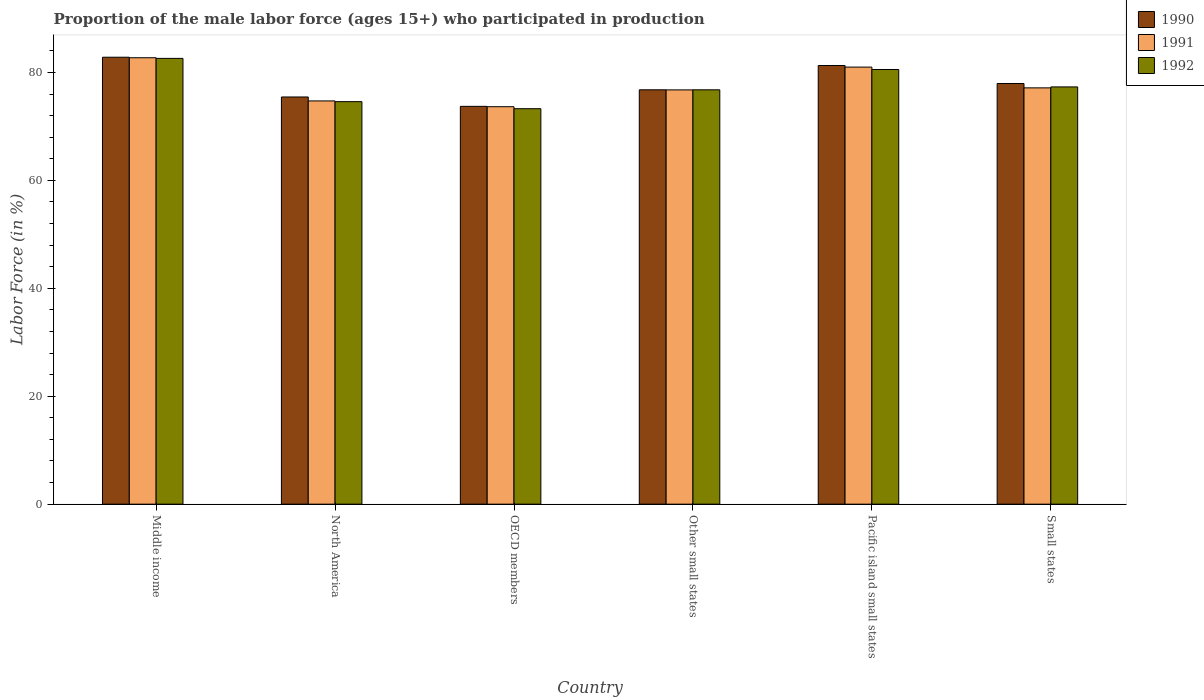How many different coloured bars are there?
Provide a succinct answer. 3. Are the number of bars per tick equal to the number of legend labels?
Your answer should be compact. Yes. Are the number of bars on each tick of the X-axis equal?
Your answer should be compact. Yes. What is the label of the 6th group of bars from the left?
Your answer should be very brief. Small states. What is the proportion of the male labor force who participated in production in 1992 in North America?
Make the answer very short. 74.6. Across all countries, what is the maximum proportion of the male labor force who participated in production in 1992?
Your answer should be very brief. 82.61. Across all countries, what is the minimum proportion of the male labor force who participated in production in 1990?
Make the answer very short. 73.73. What is the total proportion of the male labor force who participated in production in 1991 in the graph?
Keep it short and to the point. 466.05. What is the difference between the proportion of the male labor force who participated in production in 1990 in North America and that in Small states?
Keep it short and to the point. -2.5. What is the difference between the proportion of the male labor force who participated in production in 1991 in Middle income and the proportion of the male labor force who participated in production in 1992 in Pacific island small states?
Keep it short and to the point. 2.18. What is the average proportion of the male labor force who participated in production in 1991 per country?
Provide a succinct answer. 77.67. What is the difference between the proportion of the male labor force who participated in production of/in 1991 and proportion of the male labor force who participated in production of/in 1992 in Middle income?
Give a very brief answer. 0.12. What is the ratio of the proportion of the male labor force who participated in production in 1990 in Middle income to that in Pacific island small states?
Your answer should be compact. 1.02. What is the difference between the highest and the second highest proportion of the male labor force who participated in production in 1992?
Offer a very short reply. -2.06. What is the difference between the highest and the lowest proportion of the male labor force who participated in production in 1992?
Make the answer very short. 9.32. How many bars are there?
Your answer should be very brief. 18. Are all the bars in the graph horizontal?
Give a very brief answer. No. Does the graph contain any zero values?
Provide a short and direct response. No. What is the title of the graph?
Ensure brevity in your answer.  Proportion of the male labor force (ages 15+) who participated in production. Does "1964" appear as one of the legend labels in the graph?
Make the answer very short. No. What is the label or title of the Y-axis?
Provide a short and direct response. Labor Force (in %). What is the Labor Force (in %) of 1990 in Middle income?
Your response must be concise. 82.83. What is the Labor Force (in %) of 1991 in Middle income?
Offer a terse response. 82.73. What is the Labor Force (in %) in 1992 in Middle income?
Make the answer very short. 82.61. What is the Labor Force (in %) in 1990 in North America?
Offer a terse response. 75.46. What is the Labor Force (in %) in 1991 in North America?
Ensure brevity in your answer.  74.73. What is the Labor Force (in %) in 1992 in North America?
Offer a very short reply. 74.6. What is the Labor Force (in %) in 1990 in OECD members?
Your answer should be compact. 73.73. What is the Labor Force (in %) in 1991 in OECD members?
Keep it short and to the point. 73.66. What is the Labor Force (in %) in 1992 in OECD members?
Make the answer very short. 73.29. What is the Labor Force (in %) of 1990 in Other small states?
Your response must be concise. 76.79. What is the Labor Force (in %) of 1991 in Other small states?
Your response must be concise. 76.78. What is the Labor Force (in %) in 1992 in Other small states?
Provide a short and direct response. 76.79. What is the Labor Force (in %) of 1990 in Pacific island small states?
Provide a succinct answer. 81.29. What is the Labor Force (in %) of 1991 in Pacific island small states?
Provide a short and direct response. 81. What is the Labor Force (in %) of 1992 in Pacific island small states?
Make the answer very short. 80.56. What is the Labor Force (in %) of 1990 in Small states?
Offer a very short reply. 77.96. What is the Labor Force (in %) in 1991 in Small states?
Your response must be concise. 77.15. What is the Labor Force (in %) of 1992 in Small states?
Keep it short and to the point. 77.33. Across all countries, what is the maximum Labor Force (in %) in 1990?
Ensure brevity in your answer.  82.83. Across all countries, what is the maximum Labor Force (in %) of 1991?
Offer a very short reply. 82.73. Across all countries, what is the maximum Labor Force (in %) in 1992?
Keep it short and to the point. 82.61. Across all countries, what is the minimum Labor Force (in %) of 1990?
Ensure brevity in your answer.  73.73. Across all countries, what is the minimum Labor Force (in %) in 1991?
Provide a succinct answer. 73.66. Across all countries, what is the minimum Labor Force (in %) of 1992?
Keep it short and to the point. 73.29. What is the total Labor Force (in %) in 1990 in the graph?
Your answer should be very brief. 468.06. What is the total Labor Force (in %) in 1991 in the graph?
Provide a short and direct response. 466.05. What is the total Labor Force (in %) in 1992 in the graph?
Provide a succinct answer. 465.17. What is the difference between the Labor Force (in %) in 1990 in Middle income and that in North America?
Your answer should be very brief. 7.37. What is the difference between the Labor Force (in %) of 1991 in Middle income and that in North America?
Your answer should be compact. 8. What is the difference between the Labor Force (in %) of 1992 in Middle income and that in North America?
Your answer should be very brief. 8.02. What is the difference between the Labor Force (in %) in 1990 in Middle income and that in OECD members?
Give a very brief answer. 9.1. What is the difference between the Labor Force (in %) of 1991 in Middle income and that in OECD members?
Provide a succinct answer. 9.07. What is the difference between the Labor Force (in %) in 1992 in Middle income and that in OECD members?
Make the answer very short. 9.32. What is the difference between the Labor Force (in %) of 1990 in Middle income and that in Other small states?
Offer a terse response. 6.04. What is the difference between the Labor Force (in %) in 1991 in Middle income and that in Other small states?
Your answer should be compact. 5.96. What is the difference between the Labor Force (in %) of 1992 in Middle income and that in Other small states?
Provide a short and direct response. 5.83. What is the difference between the Labor Force (in %) in 1990 in Middle income and that in Pacific island small states?
Ensure brevity in your answer.  1.54. What is the difference between the Labor Force (in %) of 1991 in Middle income and that in Pacific island small states?
Make the answer very short. 1.73. What is the difference between the Labor Force (in %) in 1992 in Middle income and that in Pacific island small states?
Offer a terse response. 2.06. What is the difference between the Labor Force (in %) in 1990 in Middle income and that in Small states?
Provide a succinct answer. 4.87. What is the difference between the Labor Force (in %) in 1991 in Middle income and that in Small states?
Offer a very short reply. 5.58. What is the difference between the Labor Force (in %) in 1992 in Middle income and that in Small states?
Offer a very short reply. 5.29. What is the difference between the Labor Force (in %) of 1990 in North America and that in OECD members?
Keep it short and to the point. 1.74. What is the difference between the Labor Force (in %) in 1991 in North America and that in OECD members?
Provide a succinct answer. 1.07. What is the difference between the Labor Force (in %) of 1992 in North America and that in OECD members?
Offer a terse response. 1.31. What is the difference between the Labor Force (in %) in 1990 in North America and that in Other small states?
Provide a short and direct response. -1.33. What is the difference between the Labor Force (in %) of 1991 in North America and that in Other small states?
Make the answer very short. -2.04. What is the difference between the Labor Force (in %) in 1992 in North America and that in Other small states?
Give a very brief answer. -2.19. What is the difference between the Labor Force (in %) in 1990 in North America and that in Pacific island small states?
Your response must be concise. -5.83. What is the difference between the Labor Force (in %) of 1991 in North America and that in Pacific island small states?
Ensure brevity in your answer.  -6.27. What is the difference between the Labor Force (in %) of 1992 in North America and that in Pacific island small states?
Make the answer very short. -5.96. What is the difference between the Labor Force (in %) in 1990 in North America and that in Small states?
Your response must be concise. -2.5. What is the difference between the Labor Force (in %) of 1991 in North America and that in Small states?
Offer a terse response. -2.42. What is the difference between the Labor Force (in %) in 1992 in North America and that in Small states?
Offer a very short reply. -2.73. What is the difference between the Labor Force (in %) in 1990 in OECD members and that in Other small states?
Your answer should be compact. -3.07. What is the difference between the Labor Force (in %) of 1991 in OECD members and that in Other small states?
Provide a short and direct response. -3.12. What is the difference between the Labor Force (in %) of 1992 in OECD members and that in Other small states?
Provide a short and direct response. -3.5. What is the difference between the Labor Force (in %) in 1990 in OECD members and that in Pacific island small states?
Provide a succinct answer. -7.57. What is the difference between the Labor Force (in %) of 1991 in OECD members and that in Pacific island small states?
Provide a succinct answer. -7.34. What is the difference between the Labor Force (in %) of 1992 in OECD members and that in Pacific island small states?
Ensure brevity in your answer.  -7.27. What is the difference between the Labor Force (in %) of 1990 in OECD members and that in Small states?
Make the answer very short. -4.23. What is the difference between the Labor Force (in %) in 1991 in OECD members and that in Small states?
Keep it short and to the point. -3.49. What is the difference between the Labor Force (in %) of 1992 in OECD members and that in Small states?
Ensure brevity in your answer.  -4.04. What is the difference between the Labor Force (in %) of 1990 in Other small states and that in Pacific island small states?
Offer a very short reply. -4.5. What is the difference between the Labor Force (in %) in 1991 in Other small states and that in Pacific island small states?
Your answer should be very brief. -4.23. What is the difference between the Labor Force (in %) of 1992 in Other small states and that in Pacific island small states?
Your answer should be compact. -3.77. What is the difference between the Labor Force (in %) in 1990 in Other small states and that in Small states?
Ensure brevity in your answer.  -1.17. What is the difference between the Labor Force (in %) in 1991 in Other small states and that in Small states?
Your answer should be very brief. -0.38. What is the difference between the Labor Force (in %) of 1992 in Other small states and that in Small states?
Offer a very short reply. -0.54. What is the difference between the Labor Force (in %) of 1990 in Pacific island small states and that in Small states?
Your answer should be compact. 3.34. What is the difference between the Labor Force (in %) in 1991 in Pacific island small states and that in Small states?
Offer a terse response. 3.85. What is the difference between the Labor Force (in %) in 1992 in Pacific island small states and that in Small states?
Offer a terse response. 3.23. What is the difference between the Labor Force (in %) of 1990 in Middle income and the Labor Force (in %) of 1991 in North America?
Keep it short and to the point. 8.1. What is the difference between the Labor Force (in %) in 1990 in Middle income and the Labor Force (in %) in 1992 in North America?
Provide a succinct answer. 8.23. What is the difference between the Labor Force (in %) in 1991 in Middle income and the Labor Force (in %) in 1992 in North America?
Your answer should be compact. 8.14. What is the difference between the Labor Force (in %) in 1990 in Middle income and the Labor Force (in %) in 1991 in OECD members?
Your response must be concise. 9.17. What is the difference between the Labor Force (in %) in 1990 in Middle income and the Labor Force (in %) in 1992 in OECD members?
Make the answer very short. 9.54. What is the difference between the Labor Force (in %) in 1991 in Middle income and the Labor Force (in %) in 1992 in OECD members?
Ensure brevity in your answer.  9.44. What is the difference between the Labor Force (in %) of 1990 in Middle income and the Labor Force (in %) of 1991 in Other small states?
Your answer should be compact. 6.05. What is the difference between the Labor Force (in %) in 1990 in Middle income and the Labor Force (in %) in 1992 in Other small states?
Your answer should be very brief. 6.04. What is the difference between the Labor Force (in %) in 1991 in Middle income and the Labor Force (in %) in 1992 in Other small states?
Offer a very short reply. 5.94. What is the difference between the Labor Force (in %) in 1990 in Middle income and the Labor Force (in %) in 1991 in Pacific island small states?
Keep it short and to the point. 1.83. What is the difference between the Labor Force (in %) of 1990 in Middle income and the Labor Force (in %) of 1992 in Pacific island small states?
Offer a very short reply. 2.27. What is the difference between the Labor Force (in %) in 1991 in Middle income and the Labor Force (in %) in 1992 in Pacific island small states?
Provide a short and direct response. 2.18. What is the difference between the Labor Force (in %) in 1990 in Middle income and the Labor Force (in %) in 1991 in Small states?
Provide a succinct answer. 5.68. What is the difference between the Labor Force (in %) of 1990 in Middle income and the Labor Force (in %) of 1992 in Small states?
Your answer should be compact. 5.5. What is the difference between the Labor Force (in %) of 1991 in Middle income and the Labor Force (in %) of 1992 in Small states?
Provide a succinct answer. 5.4. What is the difference between the Labor Force (in %) in 1990 in North America and the Labor Force (in %) in 1991 in OECD members?
Offer a very short reply. 1.8. What is the difference between the Labor Force (in %) in 1990 in North America and the Labor Force (in %) in 1992 in OECD members?
Provide a succinct answer. 2.17. What is the difference between the Labor Force (in %) of 1991 in North America and the Labor Force (in %) of 1992 in OECD members?
Provide a short and direct response. 1.44. What is the difference between the Labor Force (in %) of 1990 in North America and the Labor Force (in %) of 1991 in Other small states?
Offer a very short reply. -1.31. What is the difference between the Labor Force (in %) in 1990 in North America and the Labor Force (in %) in 1992 in Other small states?
Your answer should be very brief. -1.33. What is the difference between the Labor Force (in %) of 1991 in North America and the Labor Force (in %) of 1992 in Other small states?
Offer a terse response. -2.06. What is the difference between the Labor Force (in %) in 1990 in North America and the Labor Force (in %) in 1991 in Pacific island small states?
Give a very brief answer. -5.54. What is the difference between the Labor Force (in %) in 1990 in North America and the Labor Force (in %) in 1992 in Pacific island small states?
Your response must be concise. -5.09. What is the difference between the Labor Force (in %) in 1991 in North America and the Labor Force (in %) in 1992 in Pacific island small states?
Your response must be concise. -5.82. What is the difference between the Labor Force (in %) in 1990 in North America and the Labor Force (in %) in 1991 in Small states?
Your answer should be compact. -1.69. What is the difference between the Labor Force (in %) of 1990 in North America and the Labor Force (in %) of 1992 in Small states?
Give a very brief answer. -1.87. What is the difference between the Labor Force (in %) in 1991 in North America and the Labor Force (in %) in 1992 in Small states?
Offer a terse response. -2.6. What is the difference between the Labor Force (in %) in 1990 in OECD members and the Labor Force (in %) in 1991 in Other small states?
Give a very brief answer. -3.05. What is the difference between the Labor Force (in %) in 1990 in OECD members and the Labor Force (in %) in 1992 in Other small states?
Provide a short and direct response. -3.06. What is the difference between the Labor Force (in %) in 1991 in OECD members and the Labor Force (in %) in 1992 in Other small states?
Provide a short and direct response. -3.13. What is the difference between the Labor Force (in %) in 1990 in OECD members and the Labor Force (in %) in 1991 in Pacific island small states?
Offer a very short reply. -7.27. What is the difference between the Labor Force (in %) of 1990 in OECD members and the Labor Force (in %) of 1992 in Pacific island small states?
Your response must be concise. -6.83. What is the difference between the Labor Force (in %) of 1991 in OECD members and the Labor Force (in %) of 1992 in Pacific island small states?
Your answer should be compact. -6.9. What is the difference between the Labor Force (in %) in 1990 in OECD members and the Labor Force (in %) in 1991 in Small states?
Your answer should be very brief. -3.43. What is the difference between the Labor Force (in %) in 1990 in OECD members and the Labor Force (in %) in 1992 in Small states?
Keep it short and to the point. -3.6. What is the difference between the Labor Force (in %) in 1991 in OECD members and the Labor Force (in %) in 1992 in Small states?
Offer a terse response. -3.67. What is the difference between the Labor Force (in %) of 1990 in Other small states and the Labor Force (in %) of 1991 in Pacific island small states?
Give a very brief answer. -4.21. What is the difference between the Labor Force (in %) of 1990 in Other small states and the Labor Force (in %) of 1992 in Pacific island small states?
Keep it short and to the point. -3.76. What is the difference between the Labor Force (in %) of 1991 in Other small states and the Labor Force (in %) of 1992 in Pacific island small states?
Provide a succinct answer. -3.78. What is the difference between the Labor Force (in %) in 1990 in Other small states and the Labor Force (in %) in 1991 in Small states?
Give a very brief answer. -0.36. What is the difference between the Labor Force (in %) of 1990 in Other small states and the Labor Force (in %) of 1992 in Small states?
Your answer should be compact. -0.54. What is the difference between the Labor Force (in %) in 1991 in Other small states and the Labor Force (in %) in 1992 in Small states?
Ensure brevity in your answer.  -0.55. What is the difference between the Labor Force (in %) in 1990 in Pacific island small states and the Labor Force (in %) in 1991 in Small states?
Your answer should be compact. 4.14. What is the difference between the Labor Force (in %) of 1990 in Pacific island small states and the Labor Force (in %) of 1992 in Small states?
Your answer should be compact. 3.97. What is the difference between the Labor Force (in %) in 1991 in Pacific island small states and the Labor Force (in %) in 1992 in Small states?
Ensure brevity in your answer.  3.67. What is the average Labor Force (in %) in 1990 per country?
Provide a short and direct response. 78.01. What is the average Labor Force (in %) of 1991 per country?
Offer a very short reply. 77.67. What is the average Labor Force (in %) of 1992 per country?
Your answer should be very brief. 77.53. What is the difference between the Labor Force (in %) in 1990 and Labor Force (in %) in 1991 in Middle income?
Make the answer very short. 0.1. What is the difference between the Labor Force (in %) in 1990 and Labor Force (in %) in 1992 in Middle income?
Offer a very short reply. 0.22. What is the difference between the Labor Force (in %) of 1991 and Labor Force (in %) of 1992 in Middle income?
Offer a very short reply. 0.12. What is the difference between the Labor Force (in %) in 1990 and Labor Force (in %) in 1991 in North America?
Offer a very short reply. 0.73. What is the difference between the Labor Force (in %) in 1990 and Labor Force (in %) in 1992 in North America?
Provide a short and direct response. 0.86. What is the difference between the Labor Force (in %) in 1991 and Labor Force (in %) in 1992 in North America?
Your response must be concise. 0.13. What is the difference between the Labor Force (in %) in 1990 and Labor Force (in %) in 1991 in OECD members?
Offer a very short reply. 0.07. What is the difference between the Labor Force (in %) of 1990 and Labor Force (in %) of 1992 in OECD members?
Your response must be concise. 0.44. What is the difference between the Labor Force (in %) in 1991 and Labor Force (in %) in 1992 in OECD members?
Your response must be concise. 0.37. What is the difference between the Labor Force (in %) in 1990 and Labor Force (in %) in 1991 in Other small states?
Your response must be concise. 0.02. What is the difference between the Labor Force (in %) in 1990 and Labor Force (in %) in 1992 in Other small states?
Your response must be concise. 0. What is the difference between the Labor Force (in %) in 1991 and Labor Force (in %) in 1992 in Other small states?
Provide a succinct answer. -0.01. What is the difference between the Labor Force (in %) of 1990 and Labor Force (in %) of 1991 in Pacific island small states?
Provide a succinct answer. 0.29. What is the difference between the Labor Force (in %) in 1990 and Labor Force (in %) in 1992 in Pacific island small states?
Your response must be concise. 0.74. What is the difference between the Labor Force (in %) in 1991 and Labor Force (in %) in 1992 in Pacific island small states?
Make the answer very short. 0.44. What is the difference between the Labor Force (in %) in 1990 and Labor Force (in %) in 1991 in Small states?
Offer a very short reply. 0.81. What is the difference between the Labor Force (in %) of 1990 and Labor Force (in %) of 1992 in Small states?
Ensure brevity in your answer.  0.63. What is the difference between the Labor Force (in %) in 1991 and Labor Force (in %) in 1992 in Small states?
Provide a short and direct response. -0.18. What is the ratio of the Labor Force (in %) of 1990 in Middle income to that in North America?
Your answer should be compact. 1.1. What is the ratio of the Labor Force (in %) of 1991 in Middle income to that in North America?
Your response must be concise. 1.11. What is the ratio of the Labor Force (in %) of 1992 in Middle income to that in North America?
Offer a terse response. 1.11. What is the ratio of the Labor Force (in %) in 1990 in Middle income to that in OECD members?
Keep it short and to the point. 1.12. What is the ratio of the Labor Force (in %) in 1991 in Middle income to that in OECD members?
Provide a succinct answer. 1.12. What is the ratio of the Labor Force (in %) in 1992 in Middle income to that in OECD members?
Ensure brevity in your answer.  1.13. What is the ratio of the Labor Force (in %) in 1990 in Middle income to that in Other small states?
Your answer should be compact. 1.08. What is the ratio of the Labor Force (in %) in 1991 in Middle income to that in Other small states?
Keep it short and to the point. 1.08. What is the ratio of the Labor Force (in %) of 1992 in Middle income to that in Other small states?
Provide a succinct answer. 1.08. What is the ratio of the Labor Force (in %) of 1990 in Middle income to that in Pacific island small states?
Keep it short and to the point. 1.02. What is the ratio of the Labor Force (in %) of 1991 in Middle income to that in Pacific island small states?
Your response must be concise. 1.02. What is the ratio of the Labor Force (in %) of 1992 in Middle income to that in Pacific island small states?
Your response must be concise. 1.03. What is the ratio of the Labor Force (in %) of 1991 in Middle income to that in Small states?
Offer a terse response. 1.07. What is the ratio of the Labor Force (in %) in 1992 in Middle income to that in Small states?
Your answer should be very brief. 1.07. What is the ratio of the Labor Force (in %) of 1990 in North America to that in OECD members?
Ensure brevity in your answer.  1.02. What is the ratio of the Labor Force (in %) of 1991 in North America to that in OECD members?
Give a very brief answer. 1.01. What is the ratio of the Labor Force (in %) in 1992 in North America to that in OECD members?
Provide a succinct answer. 1.02. What is the ratio of the Labor Force (in %) of 1990 in North America to that in Other small states?
Provide a succinct answer. 0.98. What is the ratio of the Labor Force (in %) in 1991 in North America to that in Other small states?
Give a very brief answer. 0.97. What is the ratio of the Labor Force (in %) in 1992 in North America to that in Other small states?
Provide a succinct answer. 0.97. What is the ratio of the Labor Force (in %) of 1990 in North America to that in Pacific island small states?
Offer a terse response. 0.93. What is the ratio of the Labor Force (in %) of 1991 in North America to that in Pacific island small states?
Give a very brief answer. 0.92. What is the ratio of the Labor Force (in %) of 1992 in North America to that in Pacific island small states?
Make the answer very short. 0.93. What is the ratio of the Labor Force (in %) of 1990 in North America to that in Small states?
Your answer should be compact. 0.97. What is the ratio of the Labor Force (in %) in 1991 in North America to that in Small states?
Make the answer very short. 0.97. What is the ratio of the Labor Force (in %) of 1992 in North America to that in Small states?
Provide a short and direct response. 0.96. What is the ratio of the Labor Force (in %) in 1990 in OECD members to that in Other small states?
Offer a terse response. 0.96. What is the ratio of the Labor Force (in %) in 1991 in OECD members to that in Other small states?
Your answer should be very brief. 0.96. What is the ratio of the Labor Force (in %) in 1992 in OECD members to that in Other small states?
Offer a very short reply. 0.95. What is the ratio of the Labor Force (in %) in 1990 in OECD members to that in Pacific island small states?
Your answer should be very brief. 0.91. What is the ratio of the Labor Force (in %) in 1991 in OECD members to that in Pacific island small states?
Ensure brevity in your answer.  0.91. What is the ratio of the Labor Force (in %) of 1992 in OECD members to that in Pacific island small states?
Provide a succinct answer. 0.91. What is the ratio of the Labor Force (in %) in 1990 in OECD members to that in Small states?
Your answer should be very brief. 0.95. What is the ratio of the Labor Force (in %) in 1991 in OECD members to that in Small states?
Your response must be concise. 0.95. What is the ratio of the Labor Force (in %) of 1992 in OECD members to that in Small states?
Give a very brief answer. 0.95. What is the ratio of the Labor Force (in %) of 1990 in Other small states to that in Pacific island small states?
Your response must be concise. 0.94. What is the ratio of the Labor Force (in %) in 1991 in Other small states to that in Pacific island small states?
Your answer should be compact. 0.95. What is the ratio of the Labor Force (in %) in 1992 in Other small states to that in Pacific island small states?
Give a very brief answer. 0.95. What is the ratio of the Labor Force (in %) in 1990 in Other small states to that in Small states?
Provide a succinct answer. 0.98. What is the ratio of the Labor Force (in %) of 1991 in Other small states to that in Small states?
Your answer should be compact. 1. What is the ratio of the Labor Force (in %) of 1990 in Pacific island small states to that in Small states?
Offer a terse response. 1.04. What is the ratio of the Labor Force (in %) in 1991 in Pacific island small states to that in Small states?
Offer a terse response. 1.05. What is the ratio of the Labor Force (in %) of 1992 in Pacific island small states to that in Small states?
Make the answer very short. 1.04. What is the difference between the highest and the second highest Labor Force (in %) in 1990?
Your answer should be compact. 1.54. What is the difference between the highest and the second highest Labor Force (in %) of 1991?
Provide a succinct answer. 1.73. What is the difference between the highest and the second highest Labor Force (in %) in 1992?
Your response must be concise. 2.06. What is the difference between the highest and the lowest Labor Force (in %) of 1990?
Your answer should be compact. 9.1. What is the difference between the highest and the lowest Labor Force (in %) of 1991?
Your answer should be very brief. 9.07. What is the difference between the highest and the lowest Labor Force (in %) in 1992?
Your response must be concise. 9.32. 